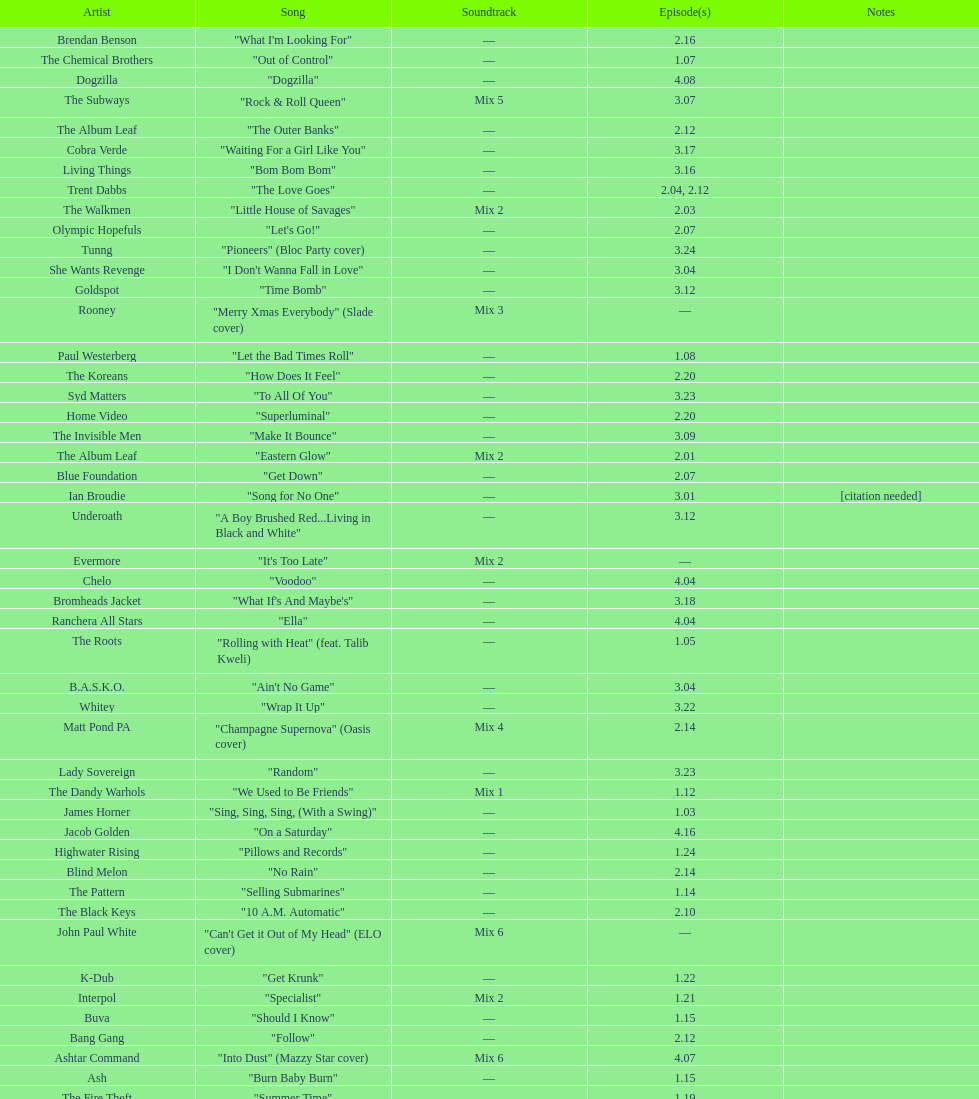The artist ash only had one song that appeared in the o.c. what is the name of that song? "Burn Baby Burn". 